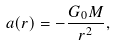Convert formula to latex. <formula><loc_0><loc_0><loc_500><loc_500>a ( r ) = - \frac { G _ { 0 } M } { r ^ { 2 } } ,</formula> 